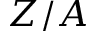<formula> <loc_0><loc_0><loc_500><loc_500>Z / A</formula> 